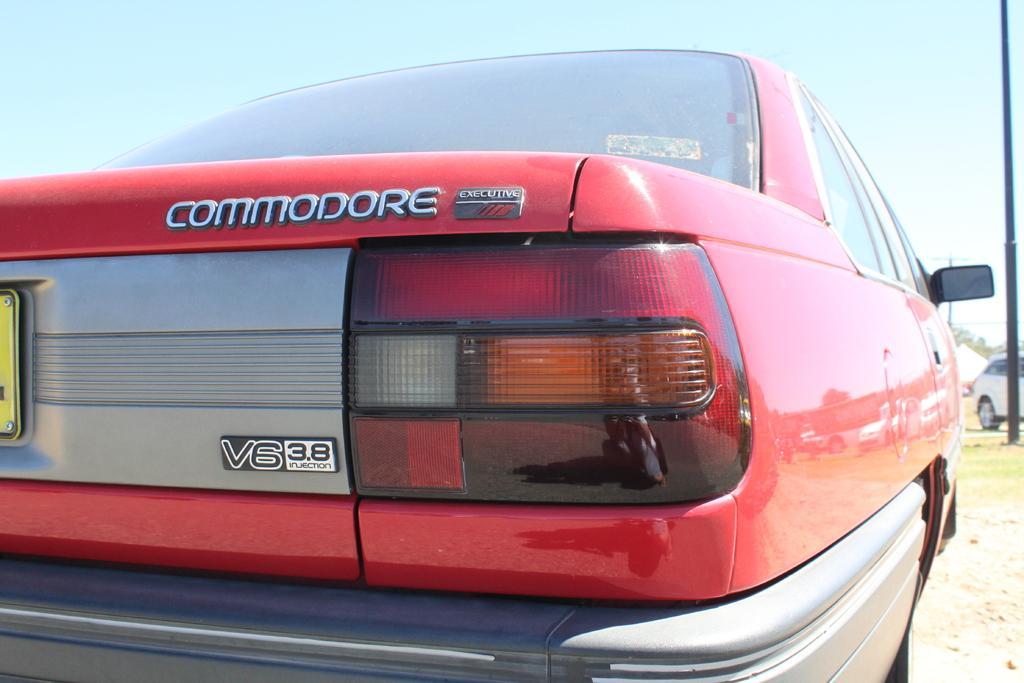Can you describe this image briefly? In this picture, we can see a few vehicles, and red color car is highlighted and we can see the ground, pole and the sky. 